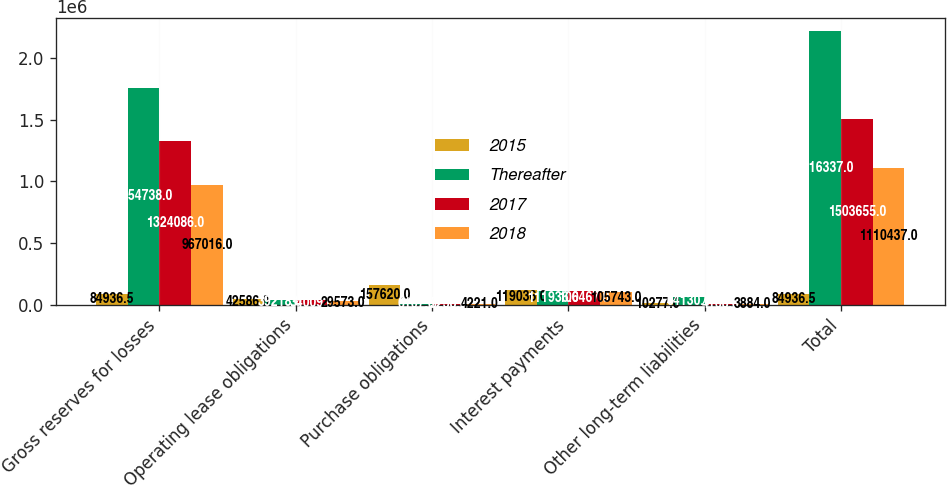Convert chart. <chart><loc_0><loc_0><loc_500><loc_500><stacked_bar_chart><ecel><fcel>Gross reserves for losses<fcel>Operating lease obligations<fcel>Purchase obligations<fcel>Interest payments<fcel>Other long-term liabilities<fcel>Total<nl><fcel>2015<fcel>84936.5<fcel>42586<fcel>157620<fcel>119036<fcel>10277<fcel>84936.5<nl><fcel>Thereafter<fcel>1.75474e+06<fcel>39218<fcel>6107<fcel>111936<fcel>64130<fcel>2.21634e+06<nl><fcel>2017<fcel>1.32409e+06<fcel>34009<fcel>5238<fcel>106467<fcel>4168<fcel>1.50366e+06<nl><fcel>2018<fcel>967016<fcel>29573<fcel>4221<fcel>105743<fcel>3884<fcel>1.11044e+06<nl></chart> 